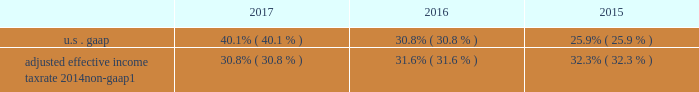Management 2019s discussion and analysis supplemental financial information and disclosures income tax matters effective tax rate from continuing operations .
Adjusted effective income tax rate 2014 non-gaap1 30.8% ( 30.8 % ) 31.6% ( 31.6 % ) 32.3% ( 32.3 % ) 1 .
Beginning in 2017 , income tax consequences associated with employee share-based awards are recognized in provision for income taxes in the income statements but are excluded from the intermittent net discrete tax provisions ( benefits ) adjustment as we anticipate conversion activity each year .
See note 2 to the financial statements on the adoption of the accounting update improvements to employee share-based payment accounting .
For 2015 , adjusted effective income tax rate also excludes dva .
For further information on non-gaap measures , see 201cselected non-gaap financial information 201d herein .
The effective tax rate from continuing operations for 2017 included an intermittent net discrete tax provision of $ 968 million , primarily related to the impact of the tax act , partially offset by net discrete tax benefits primarily associ- ated with the remeasurement of reserves and related interest due to new information regarding the status of multi-year irs tax examinations .
The tax act , enacted on december 22 , 2017 , significantly revised u.s .
Corporate income tax law by , among other things , reducing the corporate income tax rate to 21% ( 21 % ) , and implementing a modified territorial tax system that includes a one-time transition tax on deemed repatriated earnings of non-u.s .
Subsidiaries ; imposes a minimum tax on global intangible low-taxed income ( 201cgilti 201d ) and an alternative base erosion and anti-abuse tax ( 201cbeat 201d ) on u.s .
Corpora- tions that make deductible payments to non-u.s .
Related persons in excess of specified amounts ; and broadens the tax base by partially or wholly eliminating tax deductions for certain historically deductible expenses ( e.g. , fdic premiums and executive compensation ) .
We recorded an approximate $ 1.2 billion net discrete tax provision as a result of the enactment of the tax act , primarily from the remeasurement of certain deferred tax assets using the lower enacted corporate tax rate .
This provi- sion incorporates the best available information as of the enactment date as well as assumptions made based upon our current interpretation of the tax act .
Our estimates may change as we receive additional clarification and implementa- tion guidance from the u.s .
Treasury department and as the interpretation of the tax act evolves over time .
The ultimate impact of the income tax effects of the tax act will be deter- mined in connection with the preparation of our u.s .
Consoli- dated federal income tax return .
Taking into account our current assumptions , estimates and interpretations related to the tax act and other factors , we expect our effective tax rate from continuing operations for 2018 to be approximately 22% ( 22 % ) to 25% ( 25 % ) , depending on factors such as the geographic mix of earnings and employee share- based awards ( see 201cforward-looking statements 201d ) .
Subsequent to the release of the firm 2019s 2017 earnings on january 18 , 2018 , certain estimates related to the net discrete tax provision associated with the enactment of the tax act were revised , resulting in a $ 43 million increase in the provi- sion for income taxes and a reallocation of impacts among segments .
This decreased diluted eps and diluted eps from continuing operations by $ 0.03 and $ 0.02 in the fourth quarter and year ended december 31 , 2017 , respectively .
On a business segment basis , the change resulted in an $ 89 million increase in provision for income taxes for wealth management , a $ 45 million decrease for institutional securi- ties , and a $ 1 million decrease for investment management .
The effective tax rate from continuing operations for 2016 included intermittent net discrete tax benefits of $ 68 million , primarily related to the remeasurement of reserves and related interest due to new information regarding the status of multi- year irs tax examinations , partially offset by adjustments for other tax matters .
The effective tax rate from continuing operations for 2015 included intermittent net discrete tax benefits of $ 564 million , primarily associated with the repatriation of non-u.s .
Earn- ings at a cost lower than originally estimated due to an internal restructuring to simplify the legal entity organization in the u.k .
U.s .
Bank subsidiaries we provide loans to a variety of customers , from large corpo- rate and institutional clients to high net worth individuals , primarily through our u.s .
Bank subsidiaries , morgan stanley bank n.a .
( 201cmsbna 201d ) and morgan stanley private bank , national association ( 201cmspbna 201d ) ( collectively , 201cu.s .
Bank subsidiaries 201d ) .
The lending activities in the institutional securities business segment primarily include loans and lending commitments to corporate clients .
The lending activ- ities in the wealth management business segment primarily include securities-based lending that allows clients to borrow december 2017 form 10-k 52 .
What is the difference between u.s . gaap and adjusted effective income tax rate 2014non-gaap in 2017? 
Computations: (40.1 - 30.8)
Answer: 9.3. 